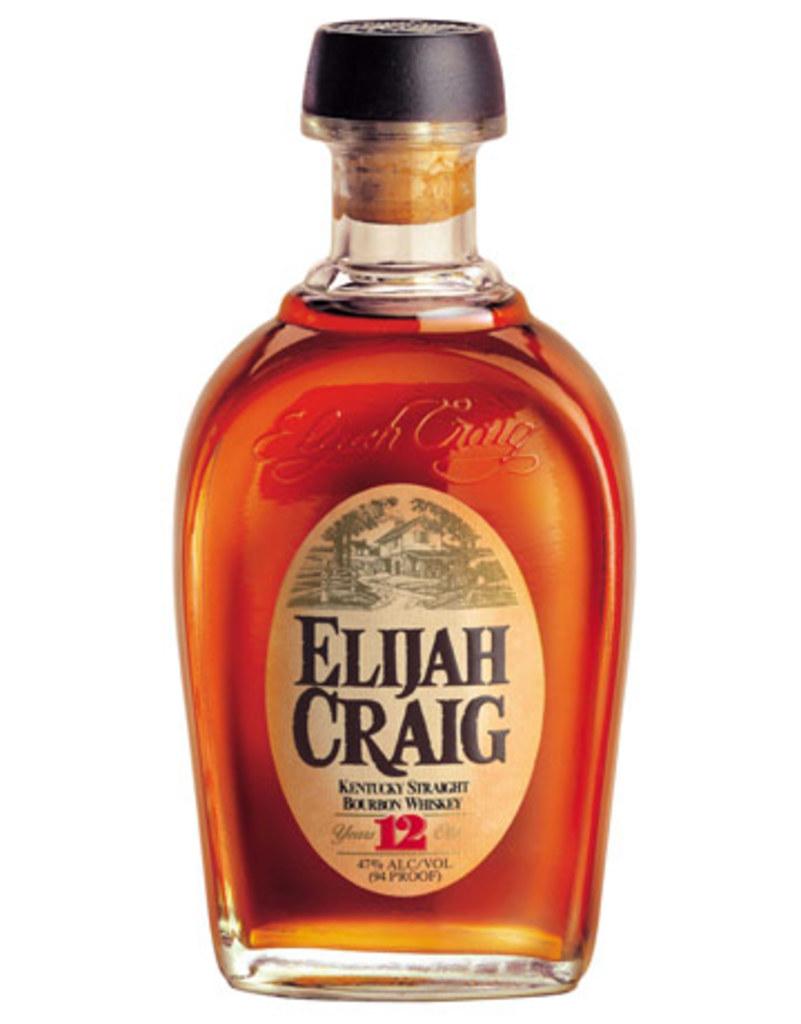What is the name on the bottle?
Your answer should be compact. Elijah craig. 